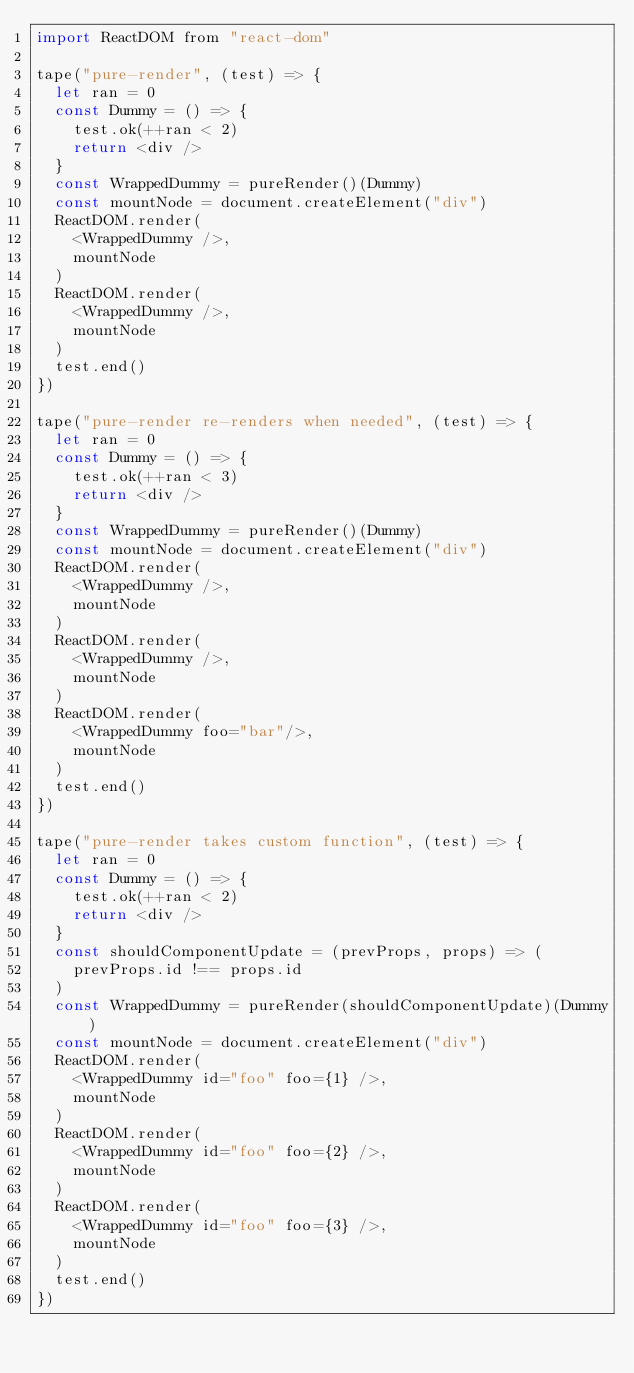Convert code to text. <code><loc_0><loc_0><loc_500><loc_500><_JavaScript_>import ReactDOM from "react-dom"

tape("pure-render", (test) => {
  let ran = 0
  const Dummy = () => {
    test.ok(++ran < 2)
    return <div />
  }
  const WrappedDummy = pureRender()(Dummy)
  const mountNode = document.createElement("div")
  ReactDOM.render(
    <WrappedDummy />,
    mountNode
  )
  ReactDOM.render(
    <WrappedDummy />,
    mountNode
  )
  test.end()
})

tape("pure-render re-renders when needed", (test) => {
  let ran = 0
  const Dummy = () => {
    test.ok(++ran < 3)
    return <div />
  }
  const WrappedDummy = pureRender()(Dummy)
  const mountNode = document.createElement("div")
  ReactDOM.render(
    <WrappedDummy />,
    mountNode
  )
  ReactDOM.render(
    <WrappedDummy />,
    mountNode
  )
  ReactDOM.render(
    <WrappedDummy foo="bar"/>,
    mountNode
  )
  test.end()
})

tape("pure-render takes custom function", (test) => {
  let ran = 0
  const Dummy = () => {
    test.ok(++ran < 2)
    return <div />
  }
  const shouldComponentUpdate = (prevProps, props) => (
    prevProps.id !== props.id
  )
  const WrappedDummy = pureRender(shouldComponentUpdate)(Dummy)
  const mountNode = document.createElement("div")
  ReactDOM.render(
    <WrappedDummy id="foo" foo={1} />,
    mountNode
  )
  ReactDOM.render(
    <WrappedDummy id="foo" foo={2} />,
    mountNode
  )
  ReactDOM.render(
    <WrappedDummy id="foo" foo={3} />,
    mountNode
  )
  test.end()
})
</code> 